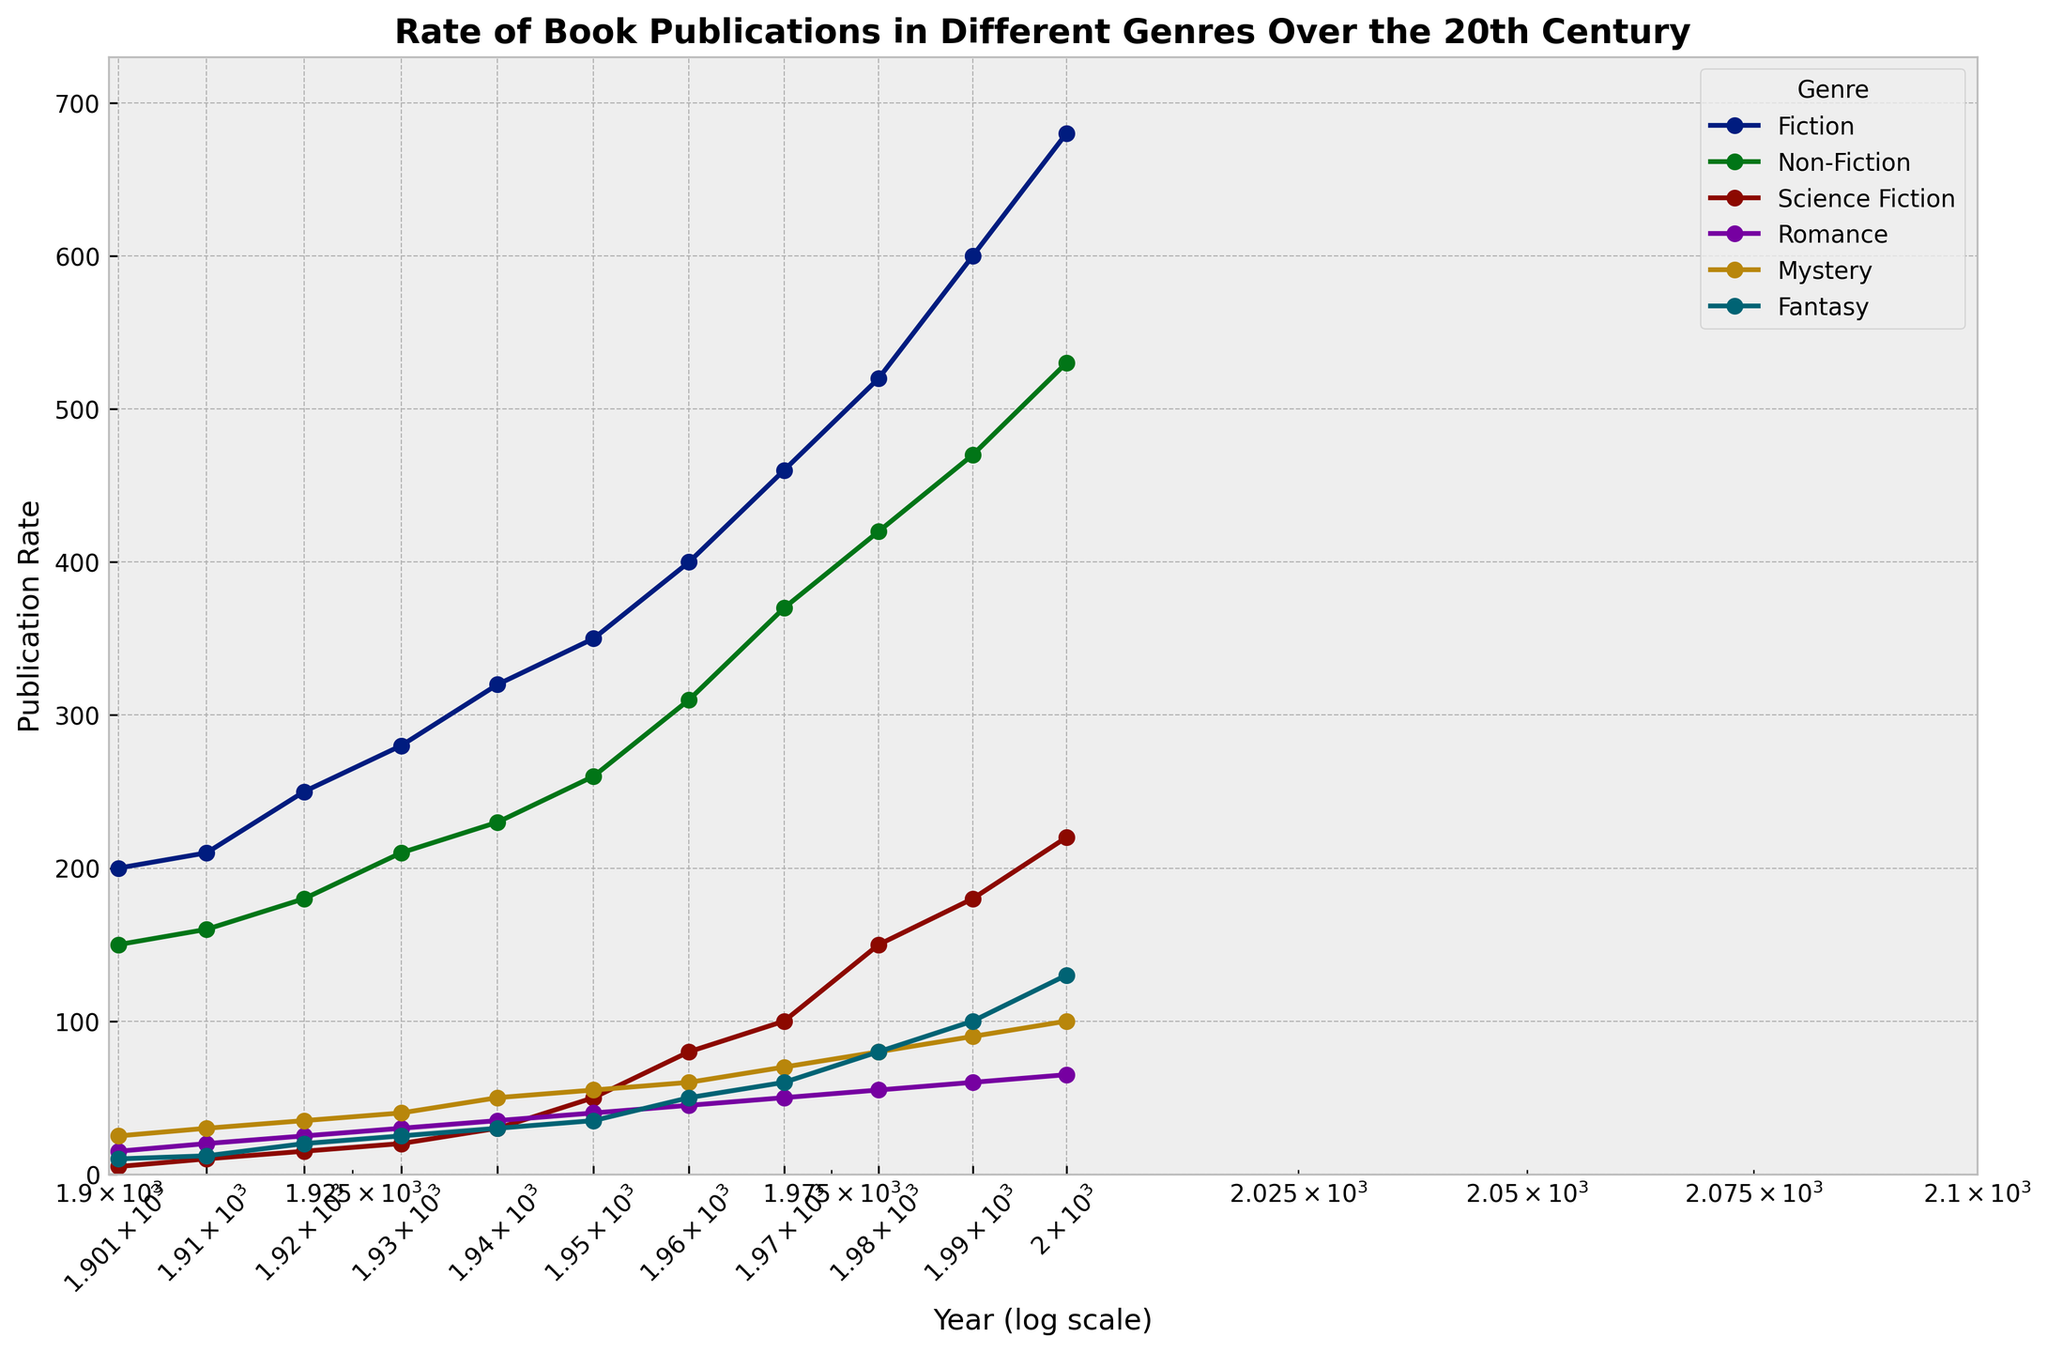what is the general trend of Fiction publication rates? The Fiction publication rate has been steadily increasing over the 20th century. Each decade shows a higher rate than the previous one. Starting around 200 in 1901 and reaching approximately 680 in 2000, it depicts a consistent upward trend.
Answer: Increasing Which genre shows the most significant growth in publication rate between 1901 and 2000? To determine the most significant growth, look at the publication rates for each genre in 1901 and 2000, then compute the difference. Science Fiction increased from 5 in 1901 to 220 in 2000, showing the most substantial increase (+215).
Answer: Science Fiction By how much did the publication rate of Non-Fiction increase from 1901 to 1950? The publication rate of Non-Fiction in 1901 was 150. In 1950, it was 260. To find the increase, subtract 150 from 260. 260 - 150 = 110.
Answer: 110 What can you infer about the publication trends of Mystery and Fantasy genres over the 20th century? Both Mystery and Fantasy genres show steady growth over the century. However, while Mystery starts at 25 in 1901 and rises to 100 in 2000 (increase of 75), Fantasy starts at 10 in 1901 and reaches 130 in 2000 (increase of 120). Fantasy shows a more substantial growth than Mystery.
Answer: Steady growth, with Fantasy growing more noticeably Which genre had the least publication rate in 1990? Review the publication rates for each genre in 1990. The genre with the lowest rate is Romance, with a publication rate of 60.
Answer: Romance Did the publication rate of Romance or Mystery grow faster between 1901 and 1920? The publication rate for Romance went from 15 in 1901 to 25 in 1920, an increase of 10. Mystery grew from 25 to 35 in the same time, an increase of 10. Both genres grew at the same rate in terms of absolute numbers, but Romance had a higher relative growth percentage-wise due to its smaller starting value.
Answer: Both grew equally in absolute terms In which decade did Fantasy first surpass a publication rate of 50? Review the publication rates for Fantasy across the decades. The publication rate surpassed 50 in the 1960s, reaching about 50.
Answer: 1960s What is the difference in publication rates between Fiction and Non-Fiction in 2000? The publication rate for Fiction in 2000 is 680, while for Non-Fiction, it is 530. The difference is calculated by subtracting 530 from 680, which equals 150.
Answer: 150 